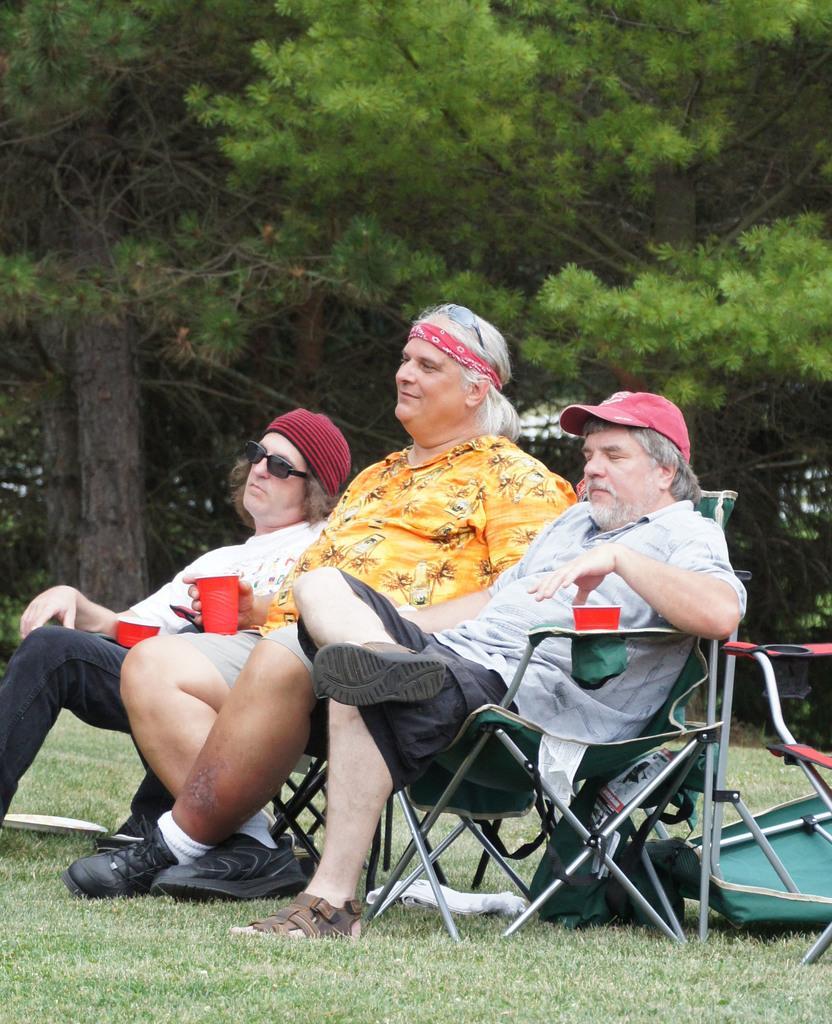In one or two sentences, can you explain what this image depicts? In this picture there is a man who is wearing cap, t-shirt, shirt and sandal. He is sitting on the chair, beside him we can see another man who is holding red glass. On the left we can see a person who is wearing goggle, t-shirt, jeans and shoe. On the bottom we can see grass. In the background we can see many trees. Here it's a sky. 